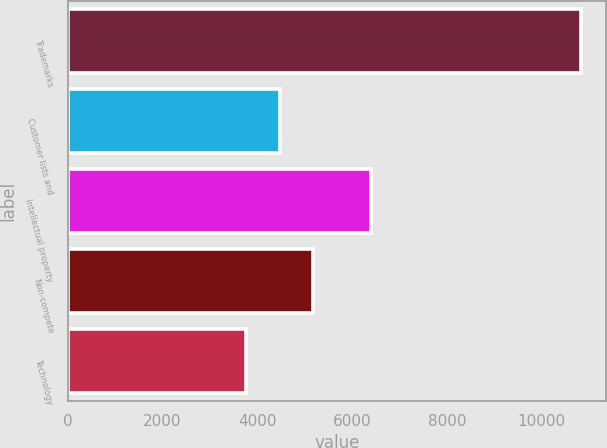Convert chart to OTSL. <chart><loc_0><loc_0><loc_500><loc_500><bar_chart><fcel>Trademarks<fcel>Customer lists and<fcel>Intellectual property<fcel>Non-compete<fcel>Technology<nl><fcel>10817<fcel>4470.2<fcel>6399<fcel>5175.4<fcel>3765<nl></chart> 